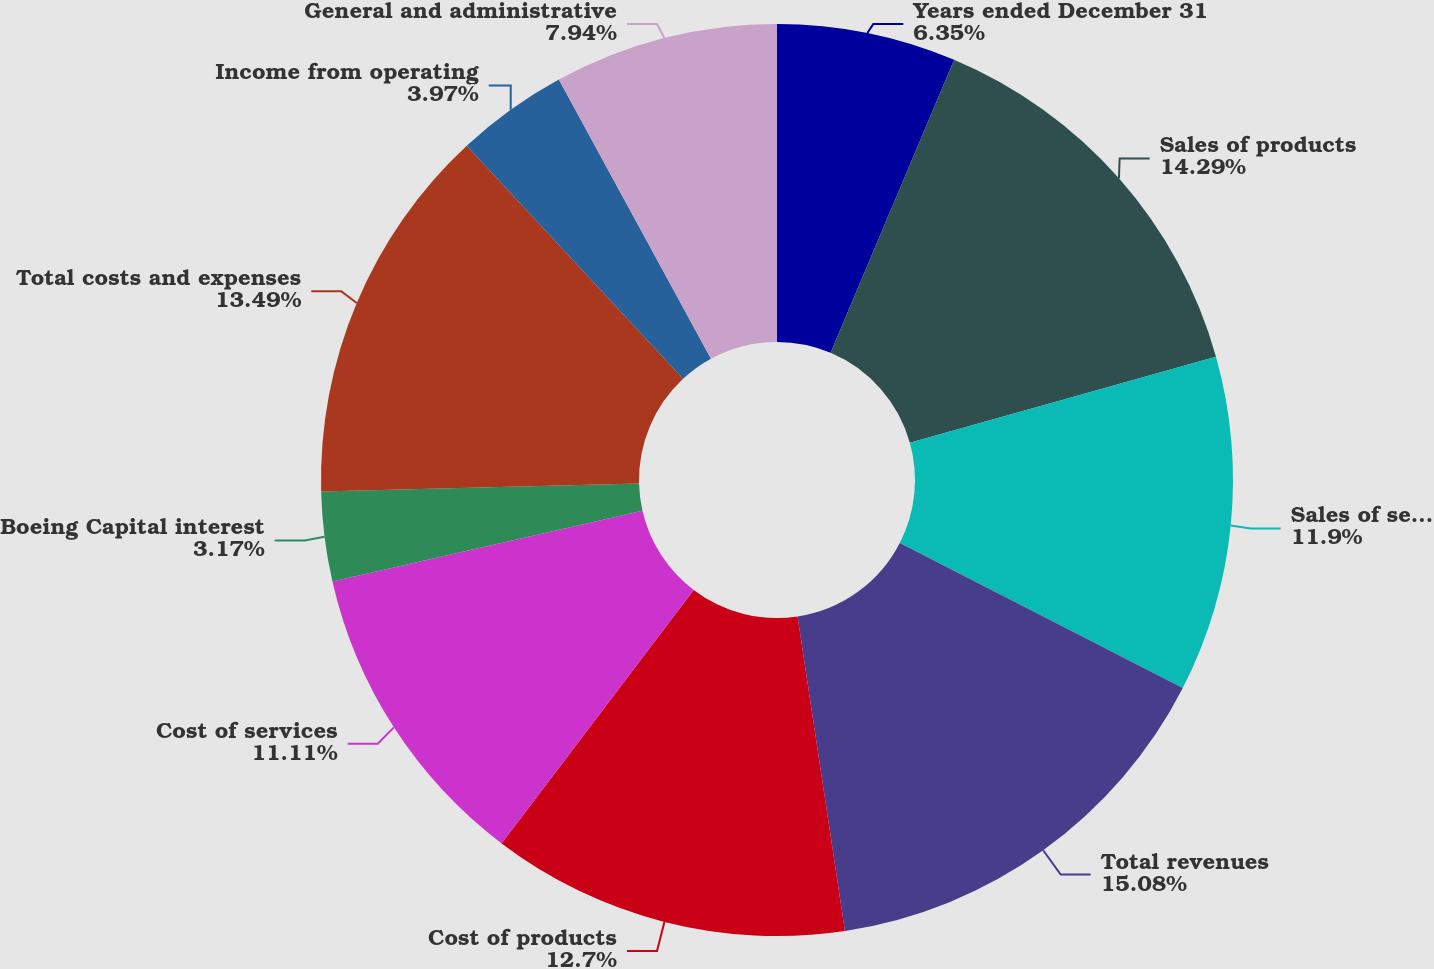Convert chart to OTSL. <chart><loc_0><loc_0><loc_500><loc_500><pie_chart><fcel>Years ended December 31<fcel>Sales of products<fcel>Sales of services<fcel>Total revenues<fcel>Cost of products<fcel>Cost of services<fcel>Boeing Capital interest<fcel>Total costs and expenses<fcel>Income from operating<fcel>General and administrative<nl><fcel>6.35%<fcel>14.29%<fcel>11.9%<fcel>15.08%<fcel>12.7%<fcel>11.11%<fcel>3.17%<fcel>13.49%<fcel>3.97%<fcel>7.94%<nl></chart> 